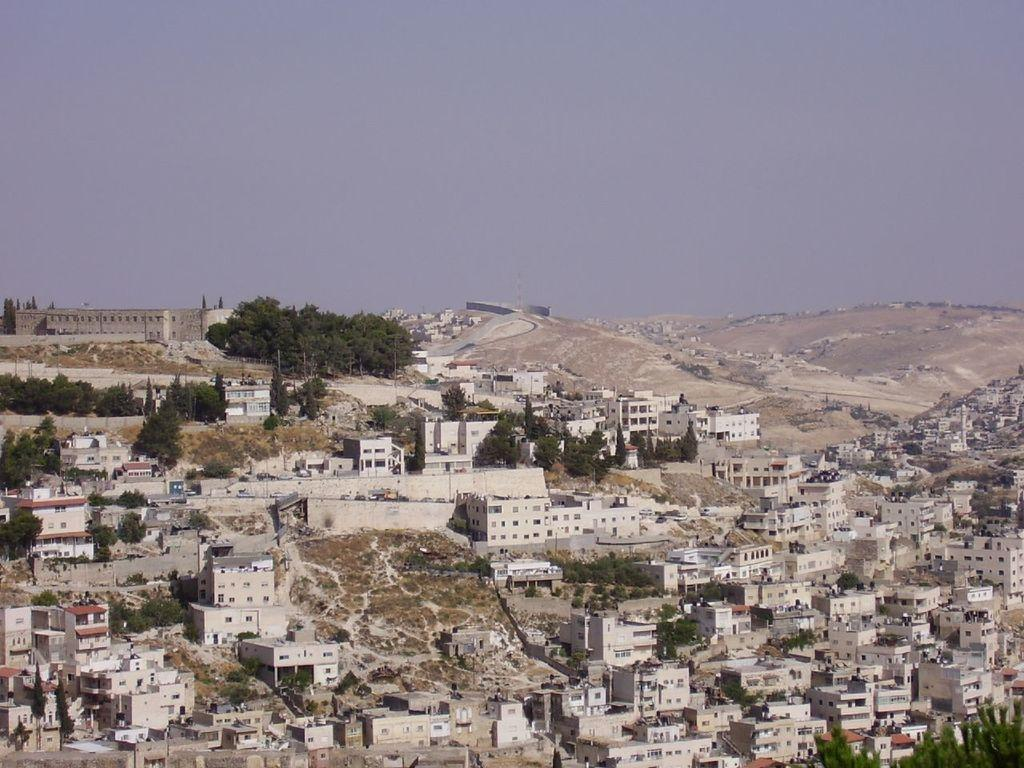What is located in the center of the image? There are buildings in the center of the image. What can be seen on the buildings in the image? Windows and roofs are visible on the buildings in the image. What type of vegetation is present in the image? Trees, plants, and grass are visible in the image. What is visible in the background of the image? The sky, a hill, and buildings are visible in the background of the image. Can you see any skateboarders riding on the roofs of the buildings in the image? There are no skateboarders or skateboards visible in the image. Are there any worms crawling on the plants in the image? There are no worms visible in the image. 